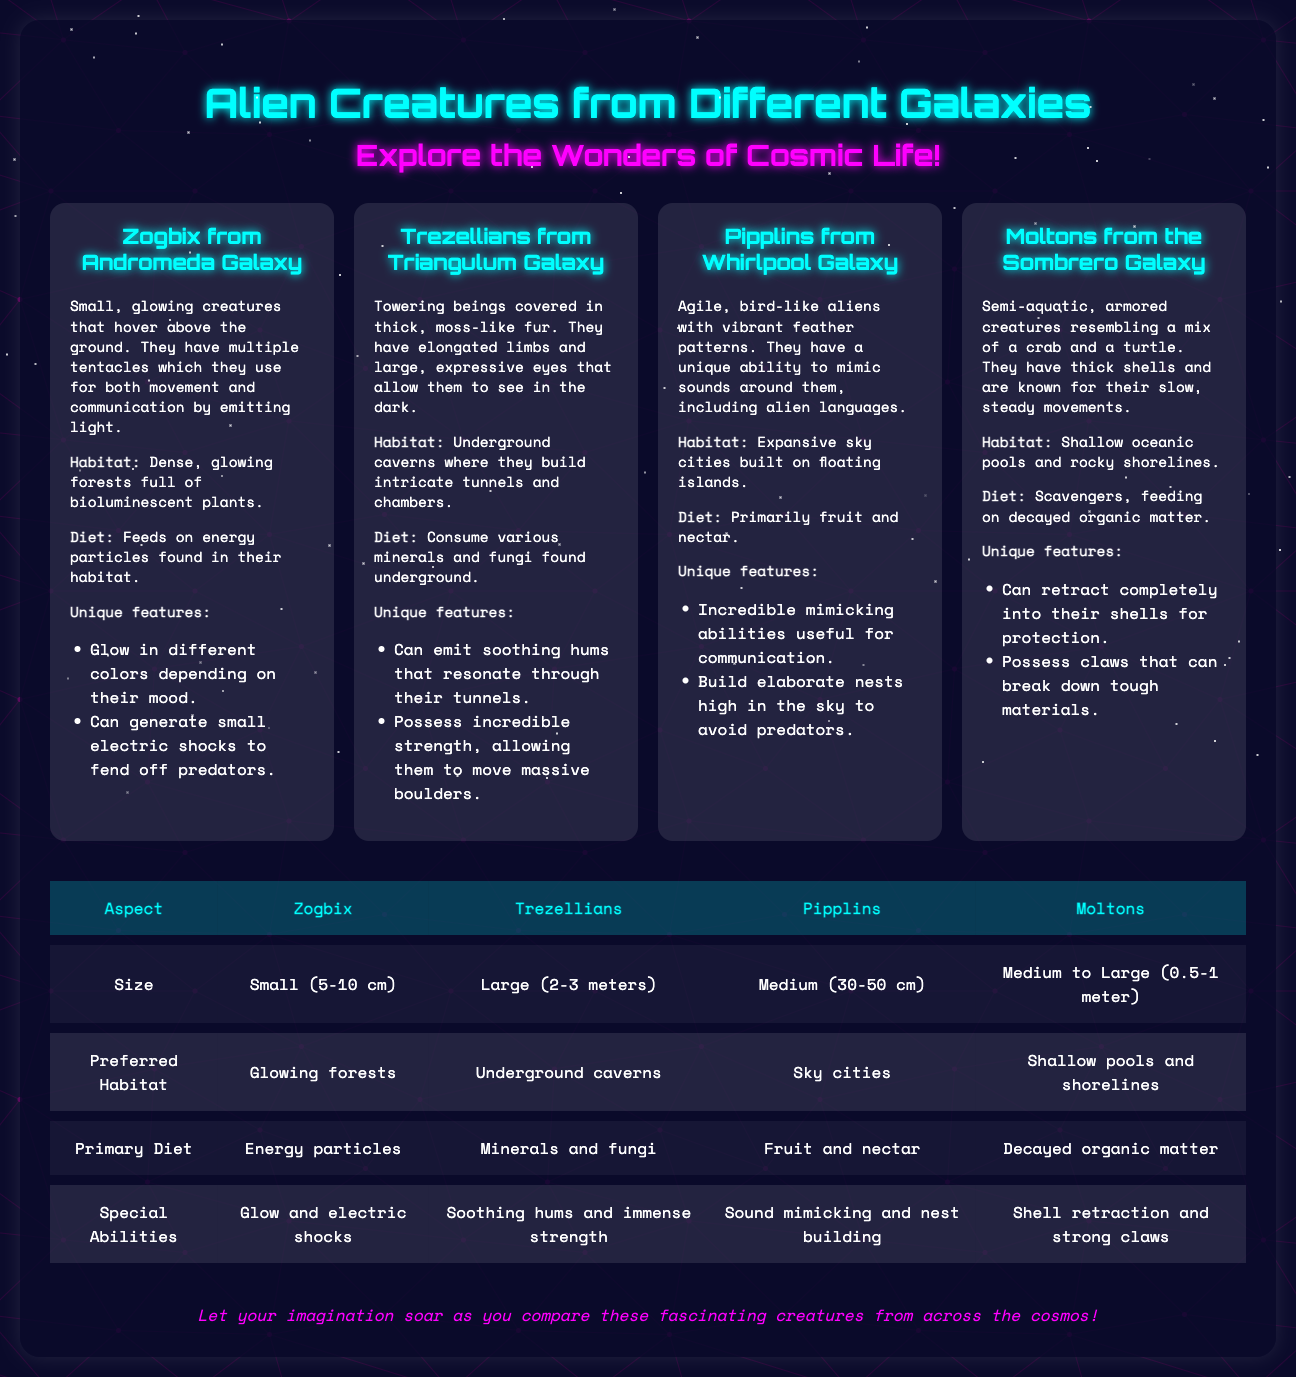What is the size of a Zogbix? The size of a Zogbix is specified in the comparison table as small, which describes the range.
Answer: Small (5-10 cm) What unique feature do Trezellians possess? The unique feature listed for Trezellians is their ability to emit soothing hums that resonate through their tunnels.
Answer: Soothing hums What is the primary diet of Pipplins? The primary diet of Pipplins is stated in the document as primarily fruit and nectar.
Answer: Fruit and nectar How do Moltons protect themselves? The document describes that Moltons can retract completely into their shells for protection.
Answer: Retract into shells Which creature is the largest according to the size comparison? The size comparison indicates that Trezellians are the largest among the creatures listed.
Answer: Large (2-3 meters) What habitat do Zogbix live in? The habitat for Zogbix is mentioned as dense, glowing forests full of bioluminescent plants.
Answer: Glowing forests How many alien creatures are compared in the infographic? The infographic contains descriptions of four alien creatures for comparison.
Answer: Four What special ability is shared by Moltons and Zogbix? The shared special ability is that both Moltons and Zogbix have unique features that allow them to navigate their environments effectively, such as defensive capabilities.
Answer: Defensive abilities (retract and glow) Which galaxy are Pipplins from? The document explicitly states that Pipplins are from the Whirlpool Galaxy.
Answer: Whirlpool Galaxy 